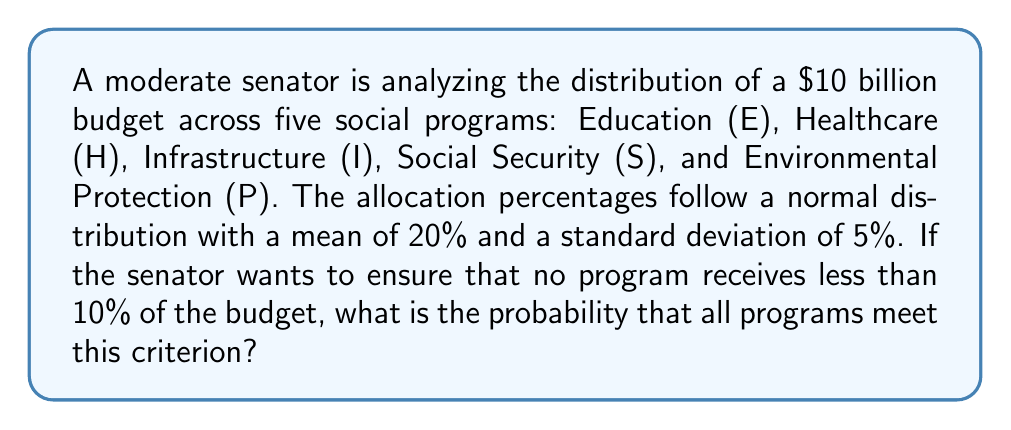Can you solve this math problem? Let's approach this step-by-step:

1) We're dealing with a normal distribution where:
   $\mu = 20\%$ and $\sigma = 5\%$

2) We need to find the probability that each program receives at least 10% of the budget. This can be expressed as:
   $P(X \geq 10\%)$ where X is the allocation percentage for a single program.

3) To calculate this, we need to standardize the value:
   $z = \frac{X - \mu}{\sigma} = \frac{10 - 20}{5} = -2$

4) Now, we need to find $P(Z \geq -2)$ using the standard normal distribution table.
   $P(Z \geq -2) = 1 - P(Z < -2) = 1 - 0.0228 = 0.9772$

5) This is the probability for a single program. Since we want all five programs to meet this criterion, and the allocations are independent, we multiply this probability by itself five times:

   $P(\text{all programs} \geq 10\%) = (0.9772)^5 = 0.8891$

6) Convert to a percentage: $0.8891 \times 100\% = 88.91\%$
Answer: 88.91% 